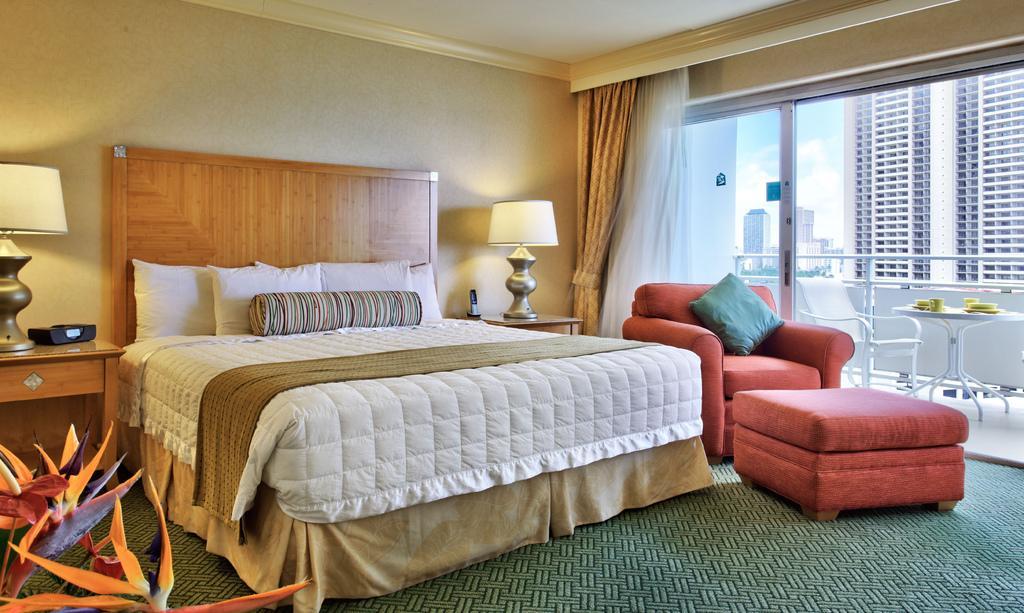Please provide a concise description of this image. In this image I can see a bed, sofa and two lamps and a flower. Here I can see number of buildings and a clear view of sky. I can also see curtains over here. 